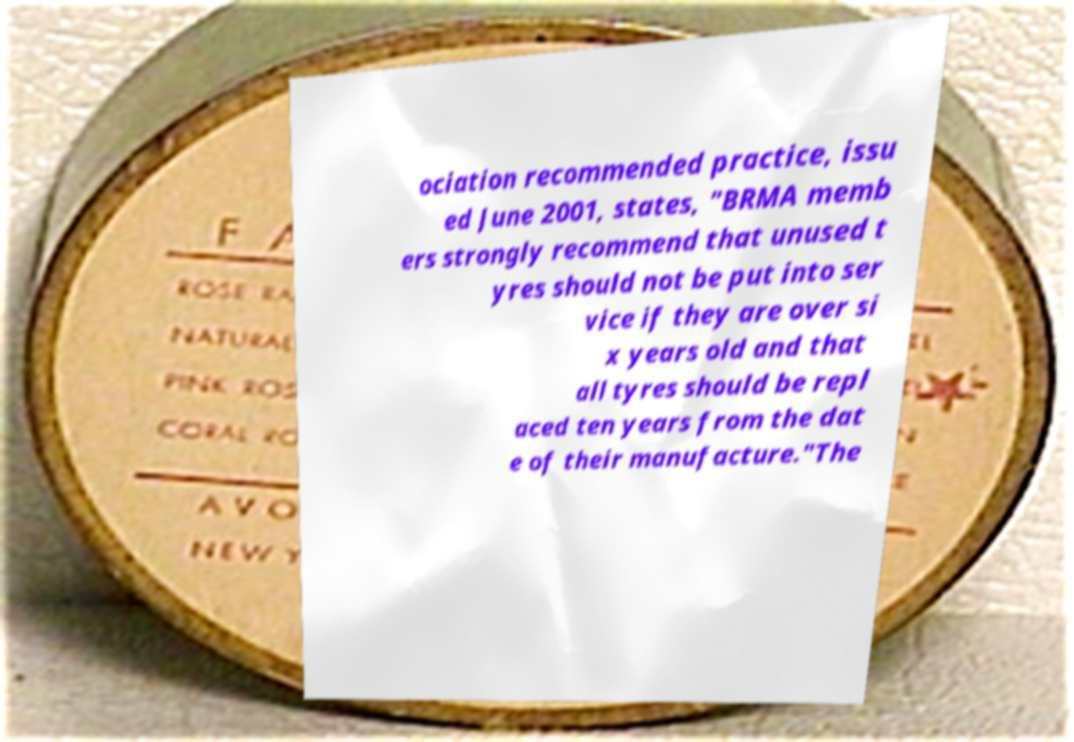Can you accurately transcribe the text from the provided image for me? ociation recommended practice, issu ed June 2001, states, "BRMA memb ers strongly recommend that unused t yres should not be put into ser vice if they are over si x years old and that all tyres should be repl aced ten years from the dat e of their manufacture."The 